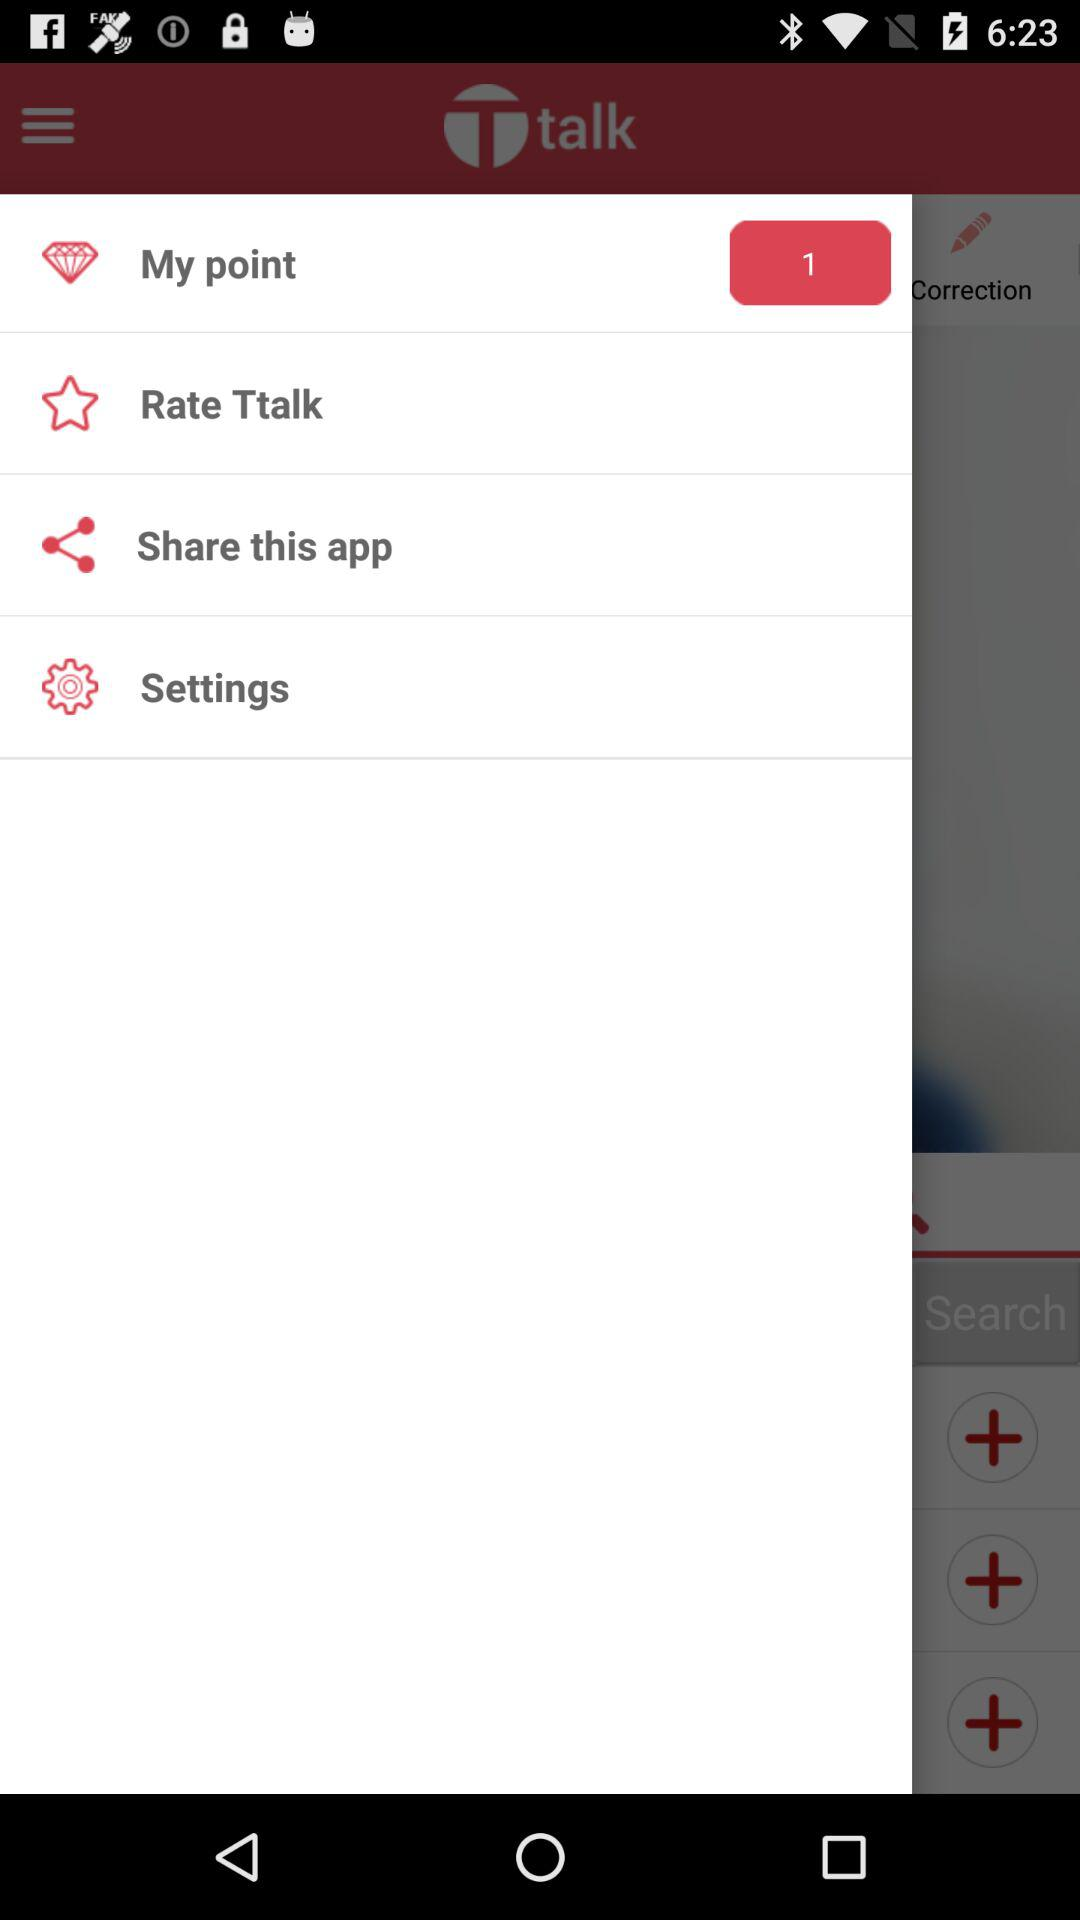What is the name of the application? The name of the application is "Ttalk". 